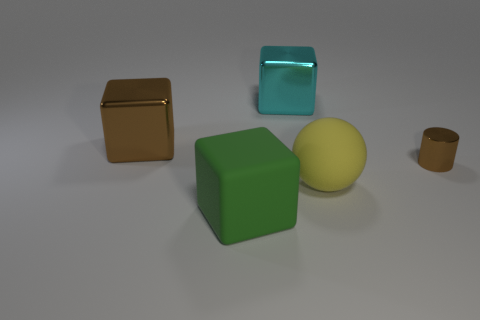Subtract all large green matte blocks. How many blocks are left? 2 Subtract all green blocks. How many blocks are left? 2 Add 4 big shiny blocks. How many objects exist? 9 Subtract 0 gray balls. How many objects are left? 5 Subtract all balls. How many objects are left? 4 Subtract 3 cubes. How many cubes are left? 0 Subtract all brown balls. Subtract all yellow blocks. How many balls are left? 1 Subtract all green blocks. Subtract all tiny metallic cylinders. How many objects are left? 3 Add 5 brown shiny blocks. How many brown shiny blocks are left? 6 Add 2 yellow things. How many yellow things exist? 3 